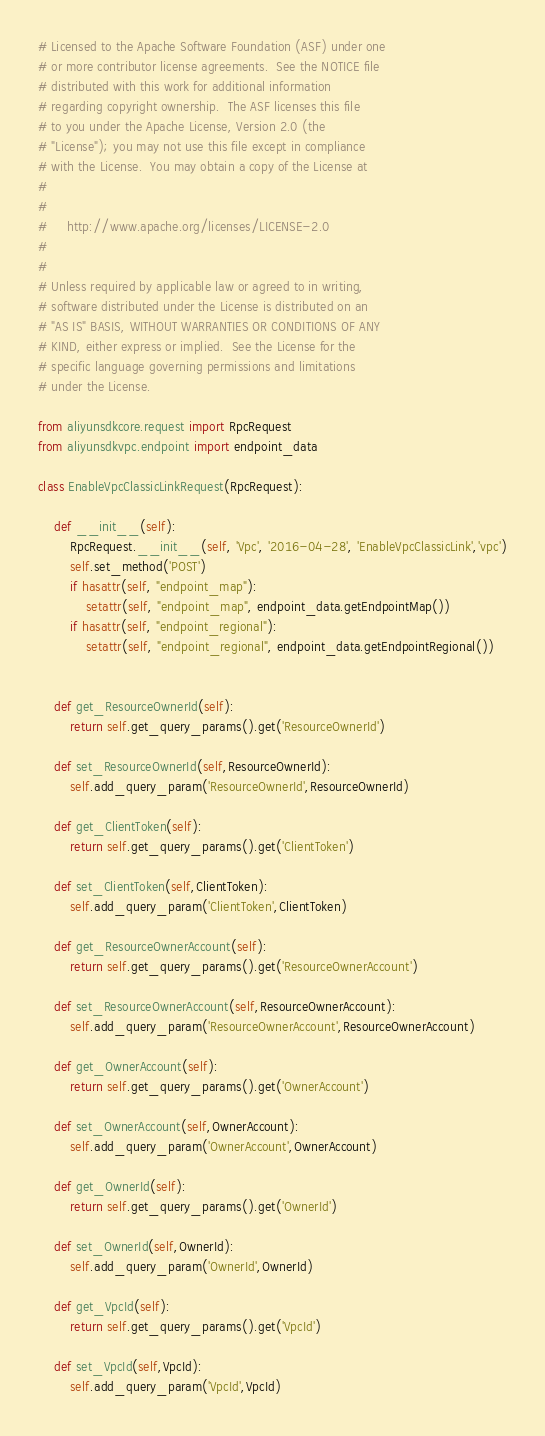Convert code to text. <code><loc_0><loc_0><loc_500><loc_500><_Python_># Licensed to the Apache Software Foundation (ASF) under one
# or more contributor license agreements.  See the NOTICE file
# distributed with this work for additional information
# regarding copyright ownership.  The ASF licenses this file
# to you under the Apache License, Version 2.0 (the
# "License"); you may not use this file except in compliance
# with the License.  You may obtain a copy of the License at
#
#
#     http://www.apache.org/licenses/LICENSE-2.0
#
#
# Unless required by applicable law or agreed to in writing,
# software distributed under the License is distributed on an
# "AS IS" BASIS, WITHOUT WARRANTIES OR CONDITIONS OF ANY
# KIND, either express or implied.  See the License for the
# specific language governing permissions and limitations
# under the License.

from aliyunsdkcore.request import RpcRequest
from aliyunsdkvpc.endpoint import endpoint_data

class EnableVpcClassicLinkRequest(RpcRequest):

	def __init__(self):
		RpcRequest.__init__(self, 'Vpc', '2016-04-28', 'EnableVpcClassicLink','vpc')
		self.set_method('POST')
		if hasattr(self, "endpoint_map"):
			setattr(self, "endpoint_map", endpoint_data.getEndpointMap())
		if hasattr(self, "endpoint_regional"):
			setattr(self, "endpoint_regional", endpoint_data.getEndpointRegional())


	def get_ResourceOwnerId(self):
		return self.get_query_params().get('ResourceOwnerId')

	def set_ResourceOwnerId(self,ResourceOwnerId):
		self.add_query_param('ResourceOwnerId',ResourceOwnerId)

	def get_ClientToken(self):
		return self.get_query_params().get('ClientToken')

	def set_ClientToken(self,ClientToken):
		self.add_query_param('ClientToken',ClientToken)

	def get_ResourceOwnerAccount(self):
		return self.get_query_params().get('ResourceOwnerAccount')

	def set_ResourceOwnerAccount(self,ResourceOwnerAccount):
		self.add_query_param('ResourceOwnerAccount',ResourceOwnerAccount)

	def get_OwnerAccount(self):
		return self.get_query_params().get('OwnerAccount')

	def set_OwnerAccount(self,OwnerAccount):
		self.add_query_param('OwnerAccount',OwnerAccount)

	def get_OwnerId(self):
		return self.get_query_params().get('OwnerId')

	def set_OwnerId(self,OwnerId):
		self.add_query_param('OwnerId',OwnerId)

	def get_VpcId(self):
		return self.get_query_params().get('VpcId')

	def set_VpcId(self,VpcId):
		self.add_query_param('VpcId',VpcId)</code> 